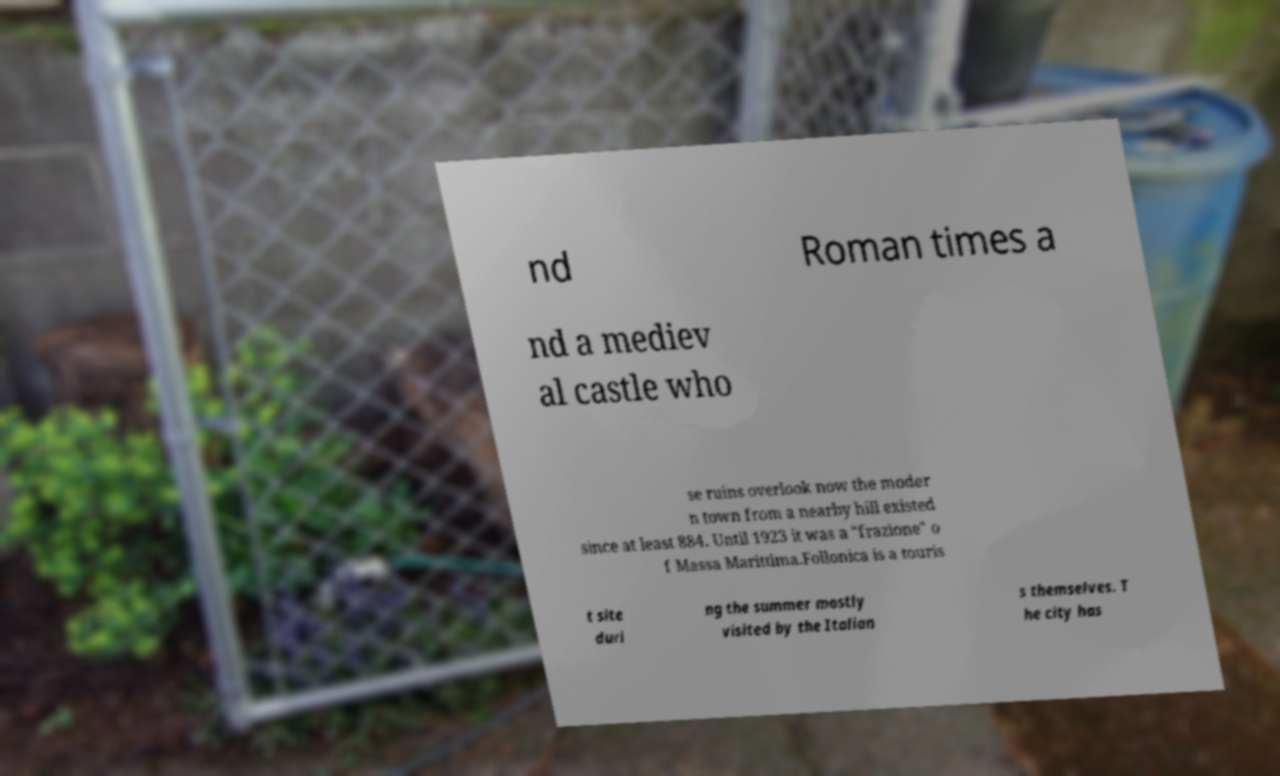For documentation purposes, I need the text within this image transcribed. Could you provide that? nd Roman times a nd a mediev al castle who se ruins overlook now the moder n town from a nearby hill existed since at least 884. Until 1923 it was a "frazione" o f Massa Marittima.Follonica is a touris t site duri ng the summer mostly visited by the Italian s themselves. T he city has 